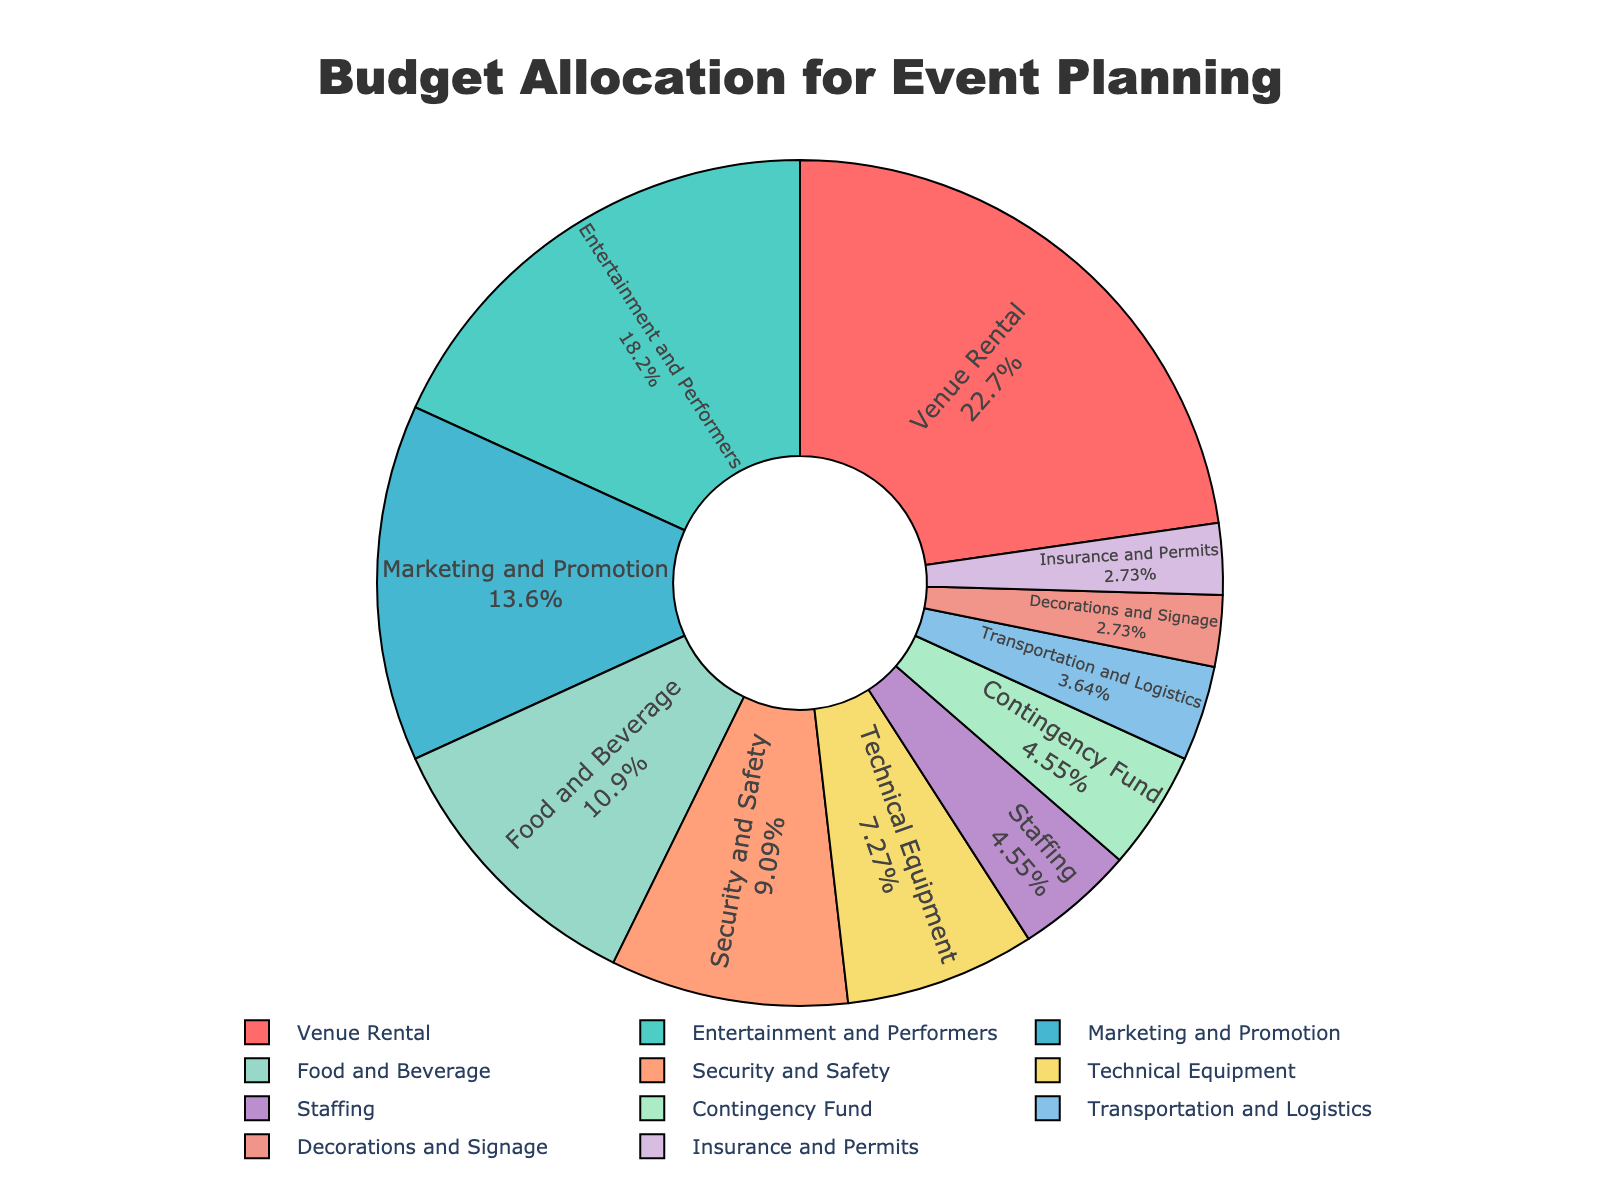What percentage of the budget is allocated to Venue Rental and Entertainment and Performers combined? First, identify the percentages for Venue Rental (25%) and Entertainment and Performers (20%). Then, sum these percentages: 25% + 20% = 45%.
Answer: 45% Which category has the smallest budget allocation, and what is its percentage? The category with the smallest allocation is Decorations and Signage with a budget of 3%.
Answer: Decorations and Signage, 3% How does the budget for Security and Safety compare to the budget for Marketing and Promotion? Identify the percentages for Security and Safety (10%) and Marketing and Promotion (15%). Observe that the budget for Marketing and Promotion is larger. The difference is 15% - 10% = 5%.
Answer: Marketing and Promotion is 5% higher than Security and Safety What's the total percentage allocated to categories with less than 5% of the budget each? Identify the categories with less than 5%: Staffing (5%), Decorations and Signage (3%), Transportation and Logistics (4%), and Insurance and Permits (3%). Sum these percentages: 5% + 3% + 4% + 3% = 15%.
Answer: 15% Which three categories have the highest budget allocation and what are their combined percentage? Identify the three categories with the highest allocation: Venue Rental (25%), Entertainment and Performers (20%), and Marketing and Promotion (15%). Sum these percentages: 25% + 20% + 15% = 60%.
Answer: Venue Rental, Entertainment and Performers, and Marketing and Promotion, 60% What is the total budget allocation for categories related to attendee experience (Food and Beverage, Entertainment and Performers, Technical Equipment)? Identify the percentages for Food and Beverage (12%), Entertainment and Performers (20%), and Technical Equipment (8%). Sum these percentages: 12% + 20% + 8% = 40%.
Answer: 40% Are there any categories with an equal budget allocation? Identify categories with the same percentage: Staffing and Contingency Fund both have a 5% allocation; Decorations and Signage, and Insurance and Permits both have a 3% allocation.
Answer: Yes, Staffing and Contingency Fund; Decorations and Signage and Insurance and Permits 